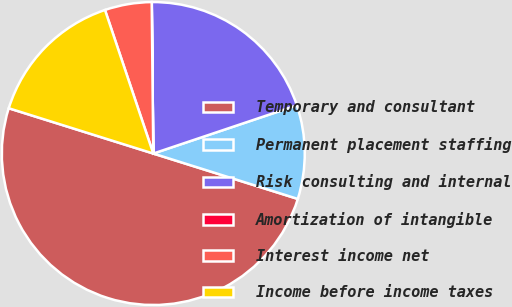<chart> <loc_0><loc_0><loc_500><loc_500><pie_chart><fcel>Temporary and consultant<fcel>Permanent placement staffing<fcel>Risk consulting and internal<fcel>Amortization of intangible<fcel>Interest income net<fcel>Income before income taxes<nl><fcel>49.99%<fcel>10.0%<fcel>20.0%<fcel>0.01%<fcel>5.0%<fcel>15.0%<nl></chart> 